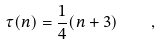Convert formula to latex. <formula><loc_0><loc_0><loc_500><loc_500>\tau ( n ) = \frac { 1 } { 4 } ( n + 3 ) \quad ,</formula> 